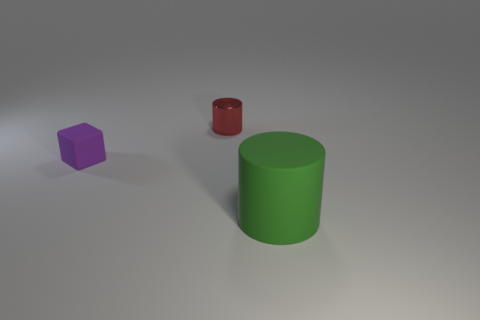Add 3 brown matte spheres. How many objects exist? 6 Subtract all red cylinders. How many cylinders are left? 1 Subtract all blocks. How many objects are left? 2 Subtract 1 cubes. How many cubes are left? 0 Subtract 0 red cubes. How many objects are left? 3 Subtract all gray blocks. Subtract all yellow balls. How many blocks are left? 1 Subtract all tiny matte blocks. Subtract all green rubber objects. How many objects are left? 1 Add 1 green things. How many green things are left? 2 Add 1 small matte balls. How many small matte balls exist? 1 